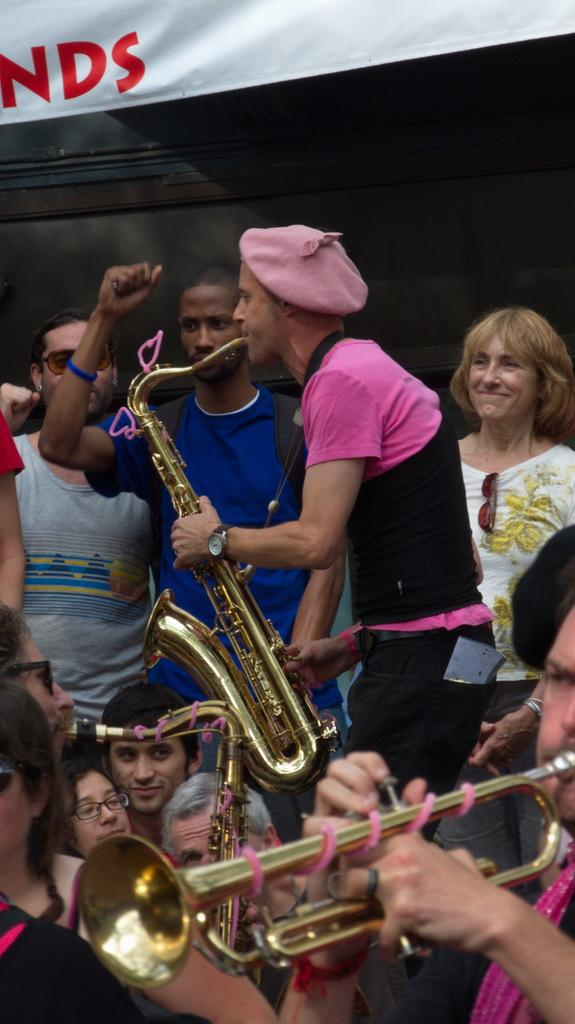How many people are in the image? There are many persons in the image. What are the three persons in the front doing? They are playing trombones in the front. What can be seen in the background of the image? There is a blackboard and a white cloth in the background. What is written or depicted on the white cloth? Text is present on the white cloth. What type of pleasure can be seen on the faces of the persons in the image? The provided facts do not mention the facial expressions or emotions of the persons in the image, so it is not possible to determine the type of pleasure they might be experiencing. 